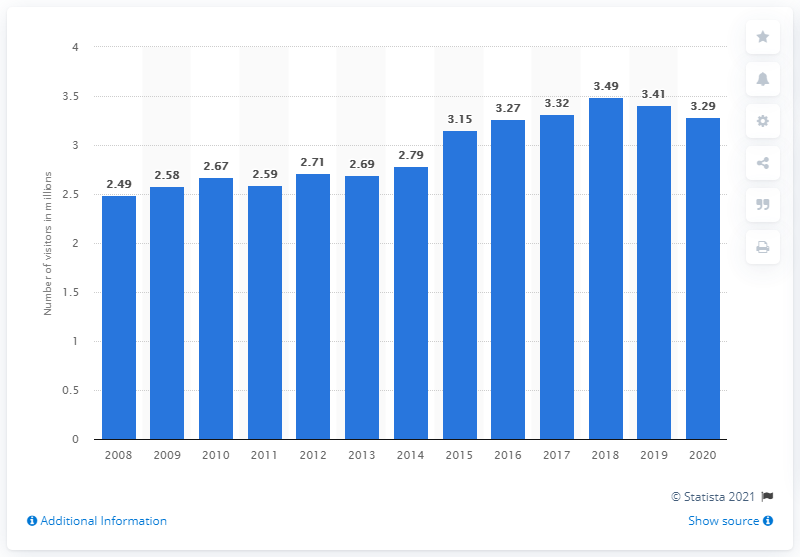Specify some key components in this picture. In 2020, the number of visitors to Grand Teton National Park was 3,290,000. 